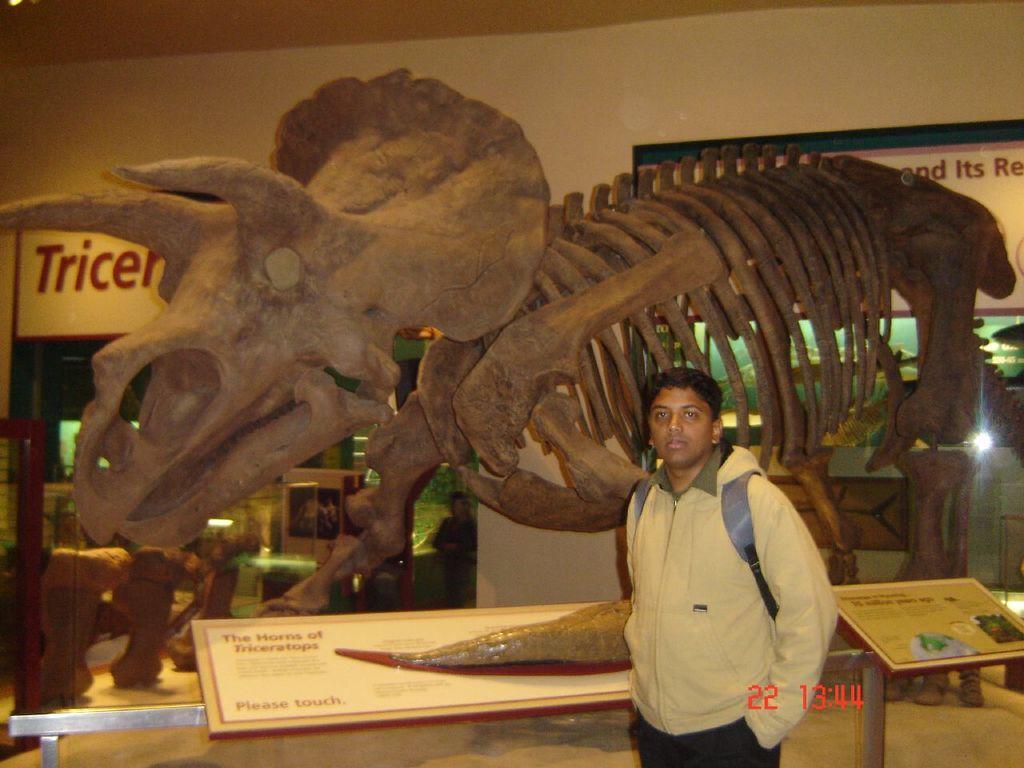How would you summarize this image in a sentence or two? In this image in front there is a person wearing a bag. Behind him there are boards on the metal rod. There is a fossil of a dinosaur. Behind the dinosaur there are a few objects. In the background of the image there is a wall. There are banners. There is some text at the bottom of the image. On the right side of the image there is a light. 